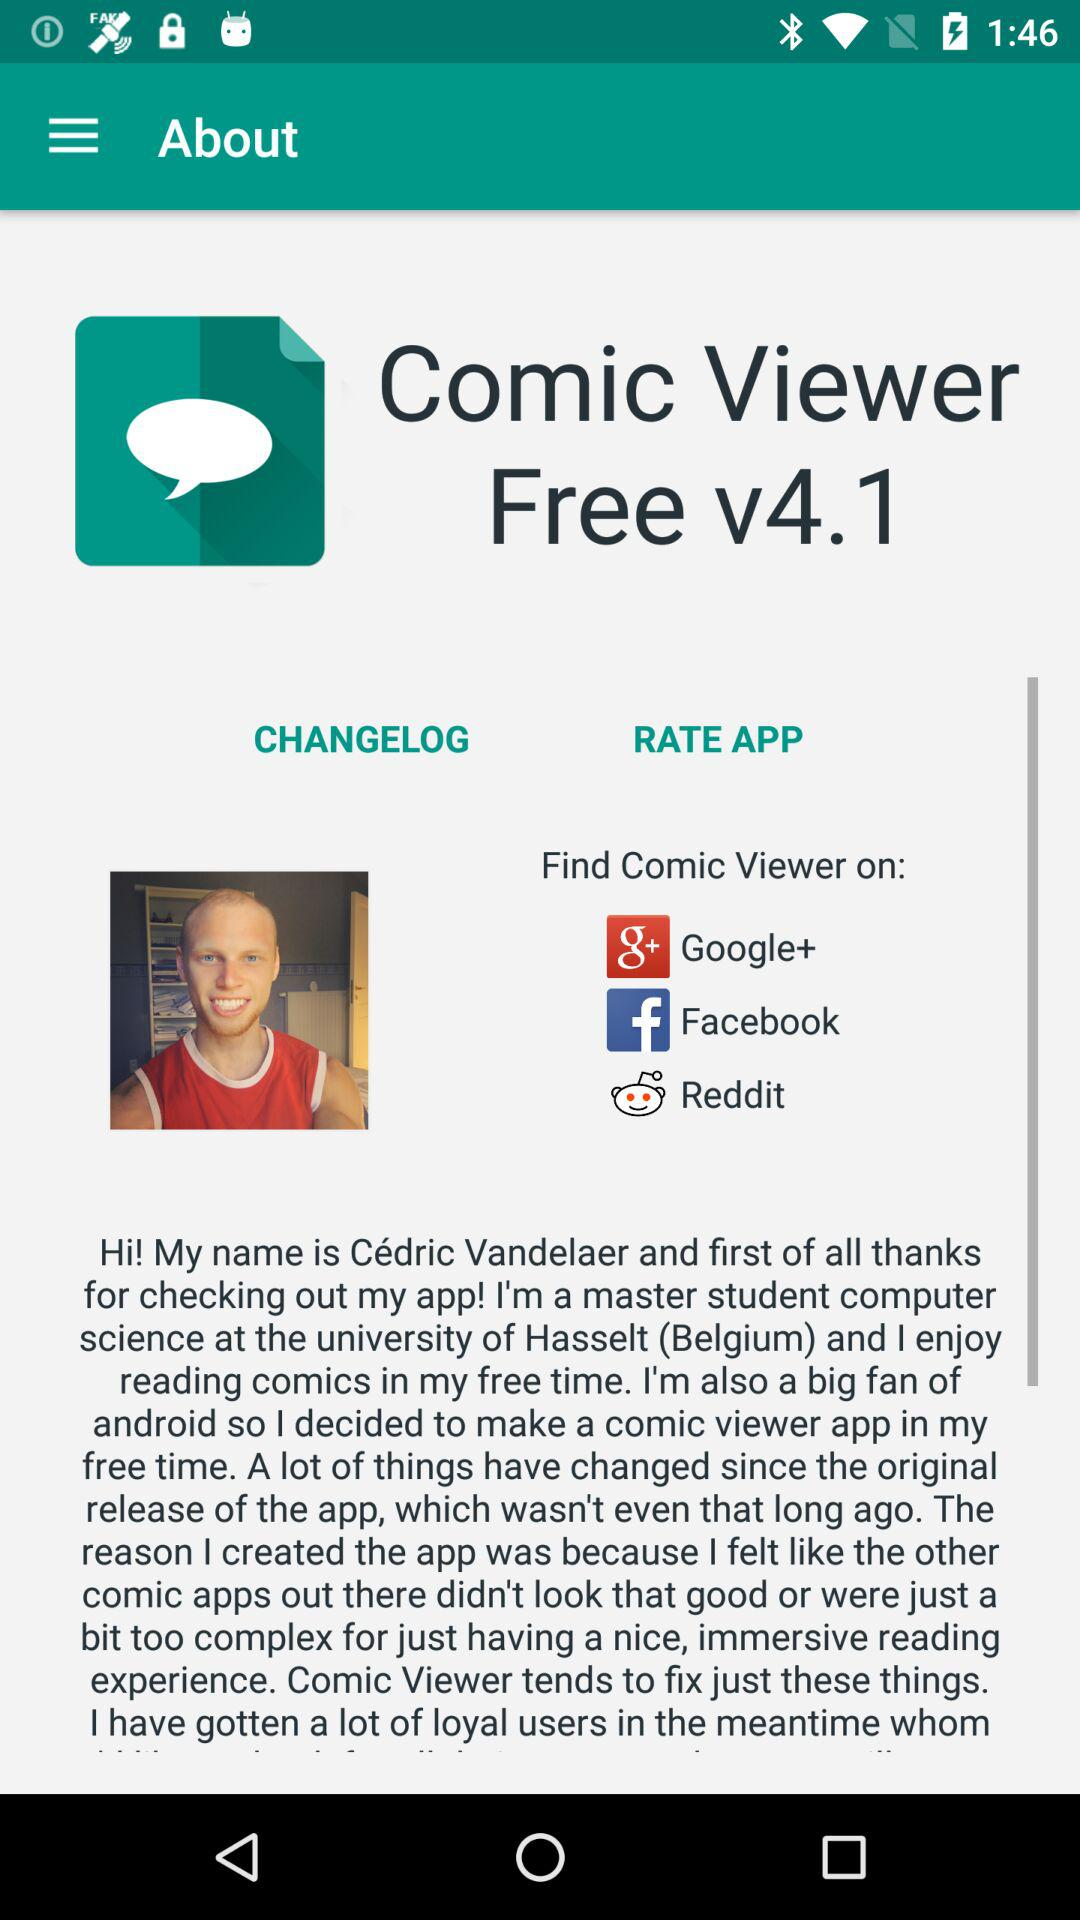Which applications are used to find more viewer?
When the provided information is insufficient, respond with <no answer>. <no answer> 